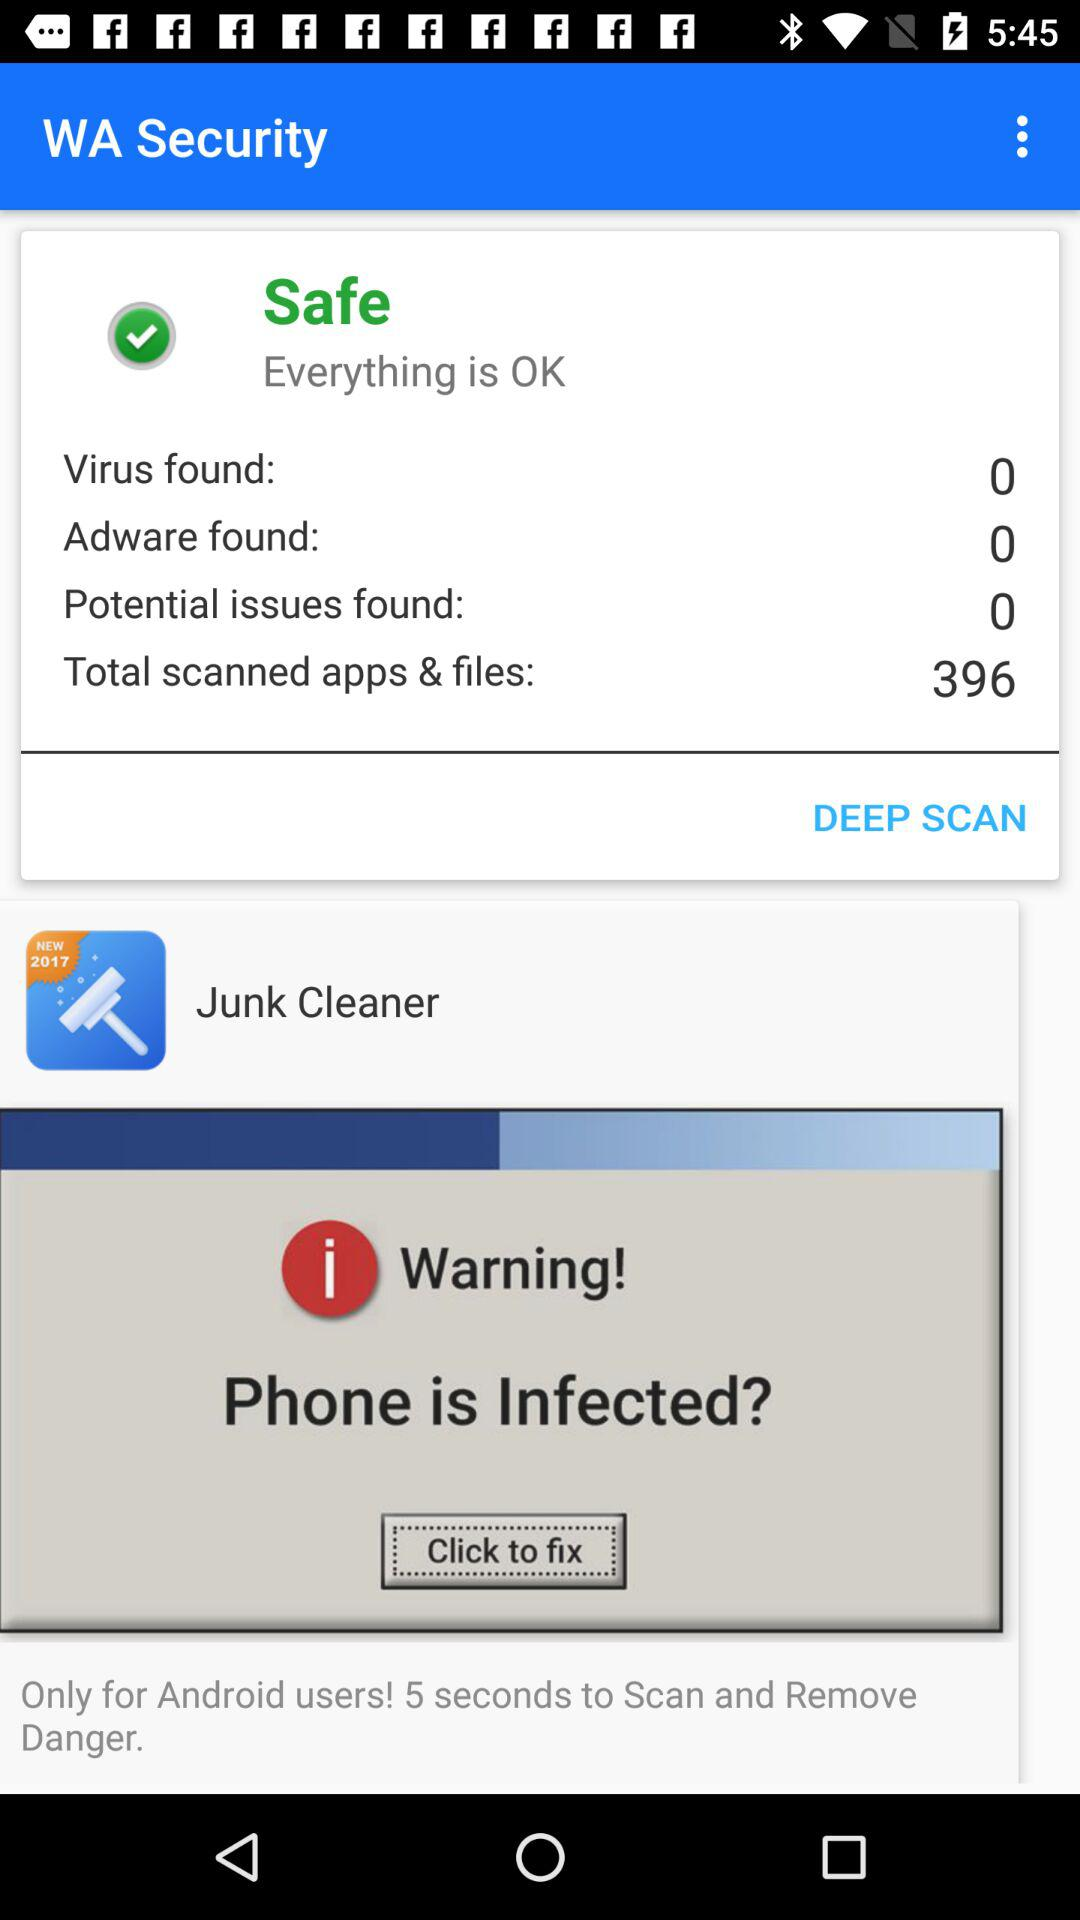What is the number of viruses found? There were zero viruses found. 